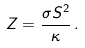Convert formula to latex. <formula><loc_0><loc_0><loc_500><loc_500>Z = \frac { \sigma S ^ { 2 } } { \kappa } \, .</formula> 